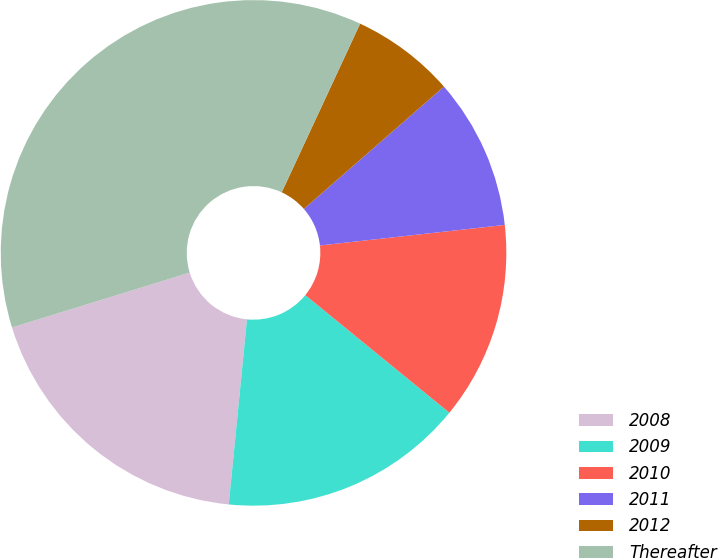Convert chart. <chart><loc_0><loc_0><loc_500><loc_500><pie_chart><fcel>2008<fcel>2009<fcel>2010<fcel>2011<fcel>2012<fcel>Thereafter<nl><fcel>18.67%<fcel>15.67%<fcel>12.66%<fcel>9.66%<fcel>6.65%<fcel>36.7%<nl></chart> 